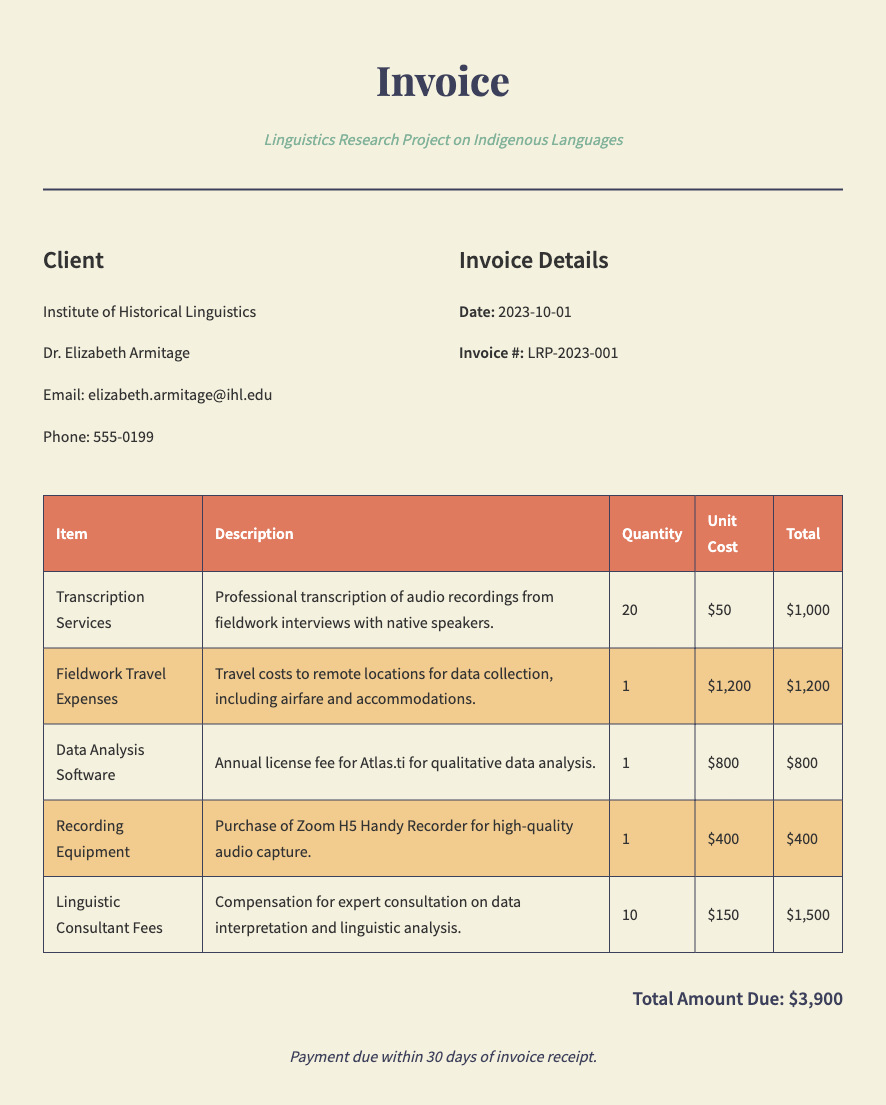What is the invoice date? The invoice date is specified in the document under invoice details, which is documented as October 1, 2023.
Answer: 2023-10-01 Who is the client? The client is listed in the document, showing the name and organization, which is the Institute of Historical Linguistics.
Answer: Institute of Historical Linguistics What is the total amount due? The total amount due is clearly stated in the document as the final amount after all expenses have been summed up.
Answer: $3,900 How many transcription services were billed? The quantity for transcription services is detailed in the document within the table of items and expenses.
Answer: 20 What is the unit cost of the data analysis software? The document lists the unit cost of the data analysis software, which is indicated in the relevant row of the expense table.
Answer: $800 What is the purpose of the fieldwork travel expenses? The description for the fieldwork travel expenses outlines the reason for these costs, which involves travel to remote locations for data collection.
Answer: Travel costs to remote locations for data collection How many linguistic consultant fees are charged? The number of linguistic consultant fees charged is mentioned in the table, indicating how many consultations were provided.
Answer: 10 What is included under the description for recording equipment? The description section of the recording equipment item explains its purpose, highlighting its use for high-quality audio capture.
Answer: Zoom H5 Handy Recorder for high-quality audio capture What are the payment terms specified in the document? The payment terms are stated towards the end of the document, outlining the timeframe for payment following the invoice receipt.
Answer: Payment due within 30 days of invoice receipt 